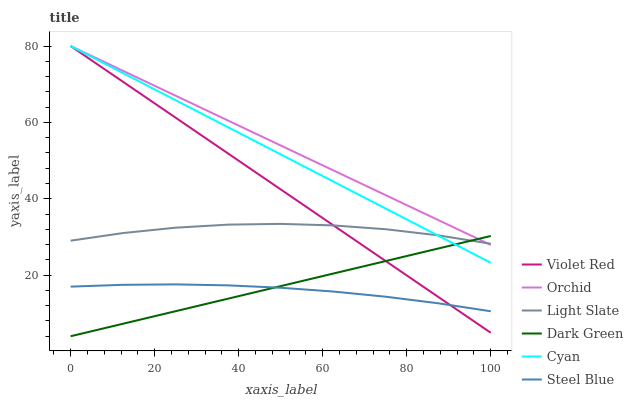Does Steel Blue have the minimum area under the curve?
Answer yes or no. Yes. Does Orchid have the maximum area under the curve?
Answer yes or no. Yes. Does Light Slate have the minimum area under the curve?
Answer yes or no. No. Does Light Slate have the maximum area under the curve?
Answer yes or no. No. Is Dark Green the smoothest?
Answer yes or no. Yes. Is Light Slate the roughest?
Answer yes or no. Yes. Is Steel Blue the smoothest?
Answer yes or no. No. Is Steel Blue the roughest?
Answer yes or no. No. Does Dark Green have the lowest value?
Answer yes or no. Yes. Does Steel Blue have the lowest value?
Answer yes or no. No. Does Orchid have the highest value?
Answer yes or no. Yes. Does Light Slate have the highest value?
Answer yes or no. No. Is Steel Blue less than Cyan?
Answer yes or no. Yes. Is Orchid greater than Steel Blue?
Answer yes or no. Yes. Does Violet Red intersect Cyan?
Answer yes or no. Yes. Is Violet Red less than Cyan?
Answer yes or no. No. Is Violet Red greater than Cyan?
Answer yes or no. No. Does Steel Blue intersect Cyan?
Answer yes or no. No. 